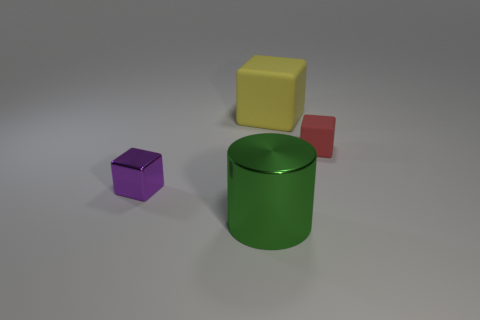Subtract all small blocks. How many blocks are left? 1 Add 1 big red rubber spheres. How many objects exist? 5 Subtract all yellow blocks. How many blocks are left? 2 Subtract all cubes. How many objects are left? 1 Subtract 1 cylinders. How many cylinders are left? 0 Subtract all purple blocks. How many purple cylinders are left? 0 Subtract all purple rubber cylinders. Subtract all tiny matte objects. How many objects are left? 3 Add 4 red objects. How many red objects are left? 5 Add 3 big purple metallic cylinders. How many big purple metallic cylinders exist? 3 Subtract 0 gray cylinders. How many objects are left? 4 